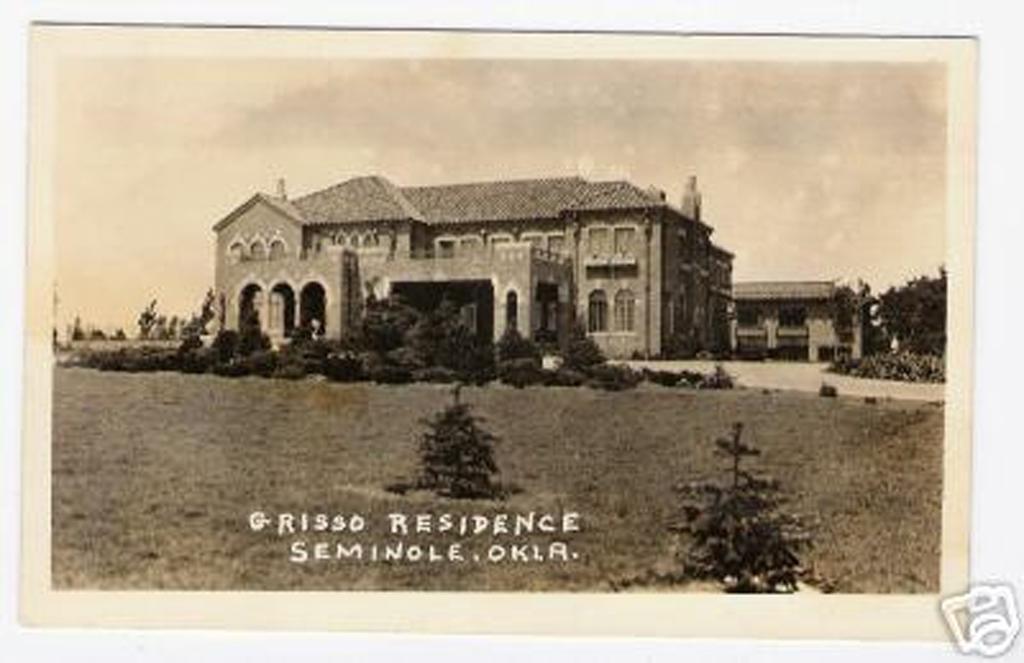Can you describe this image briefly? In the foreground of the picture there are plants, grass and text. In the middle of the picture we can see buildings, trees and plants. At the top there is sky. The picture has a white color border. 